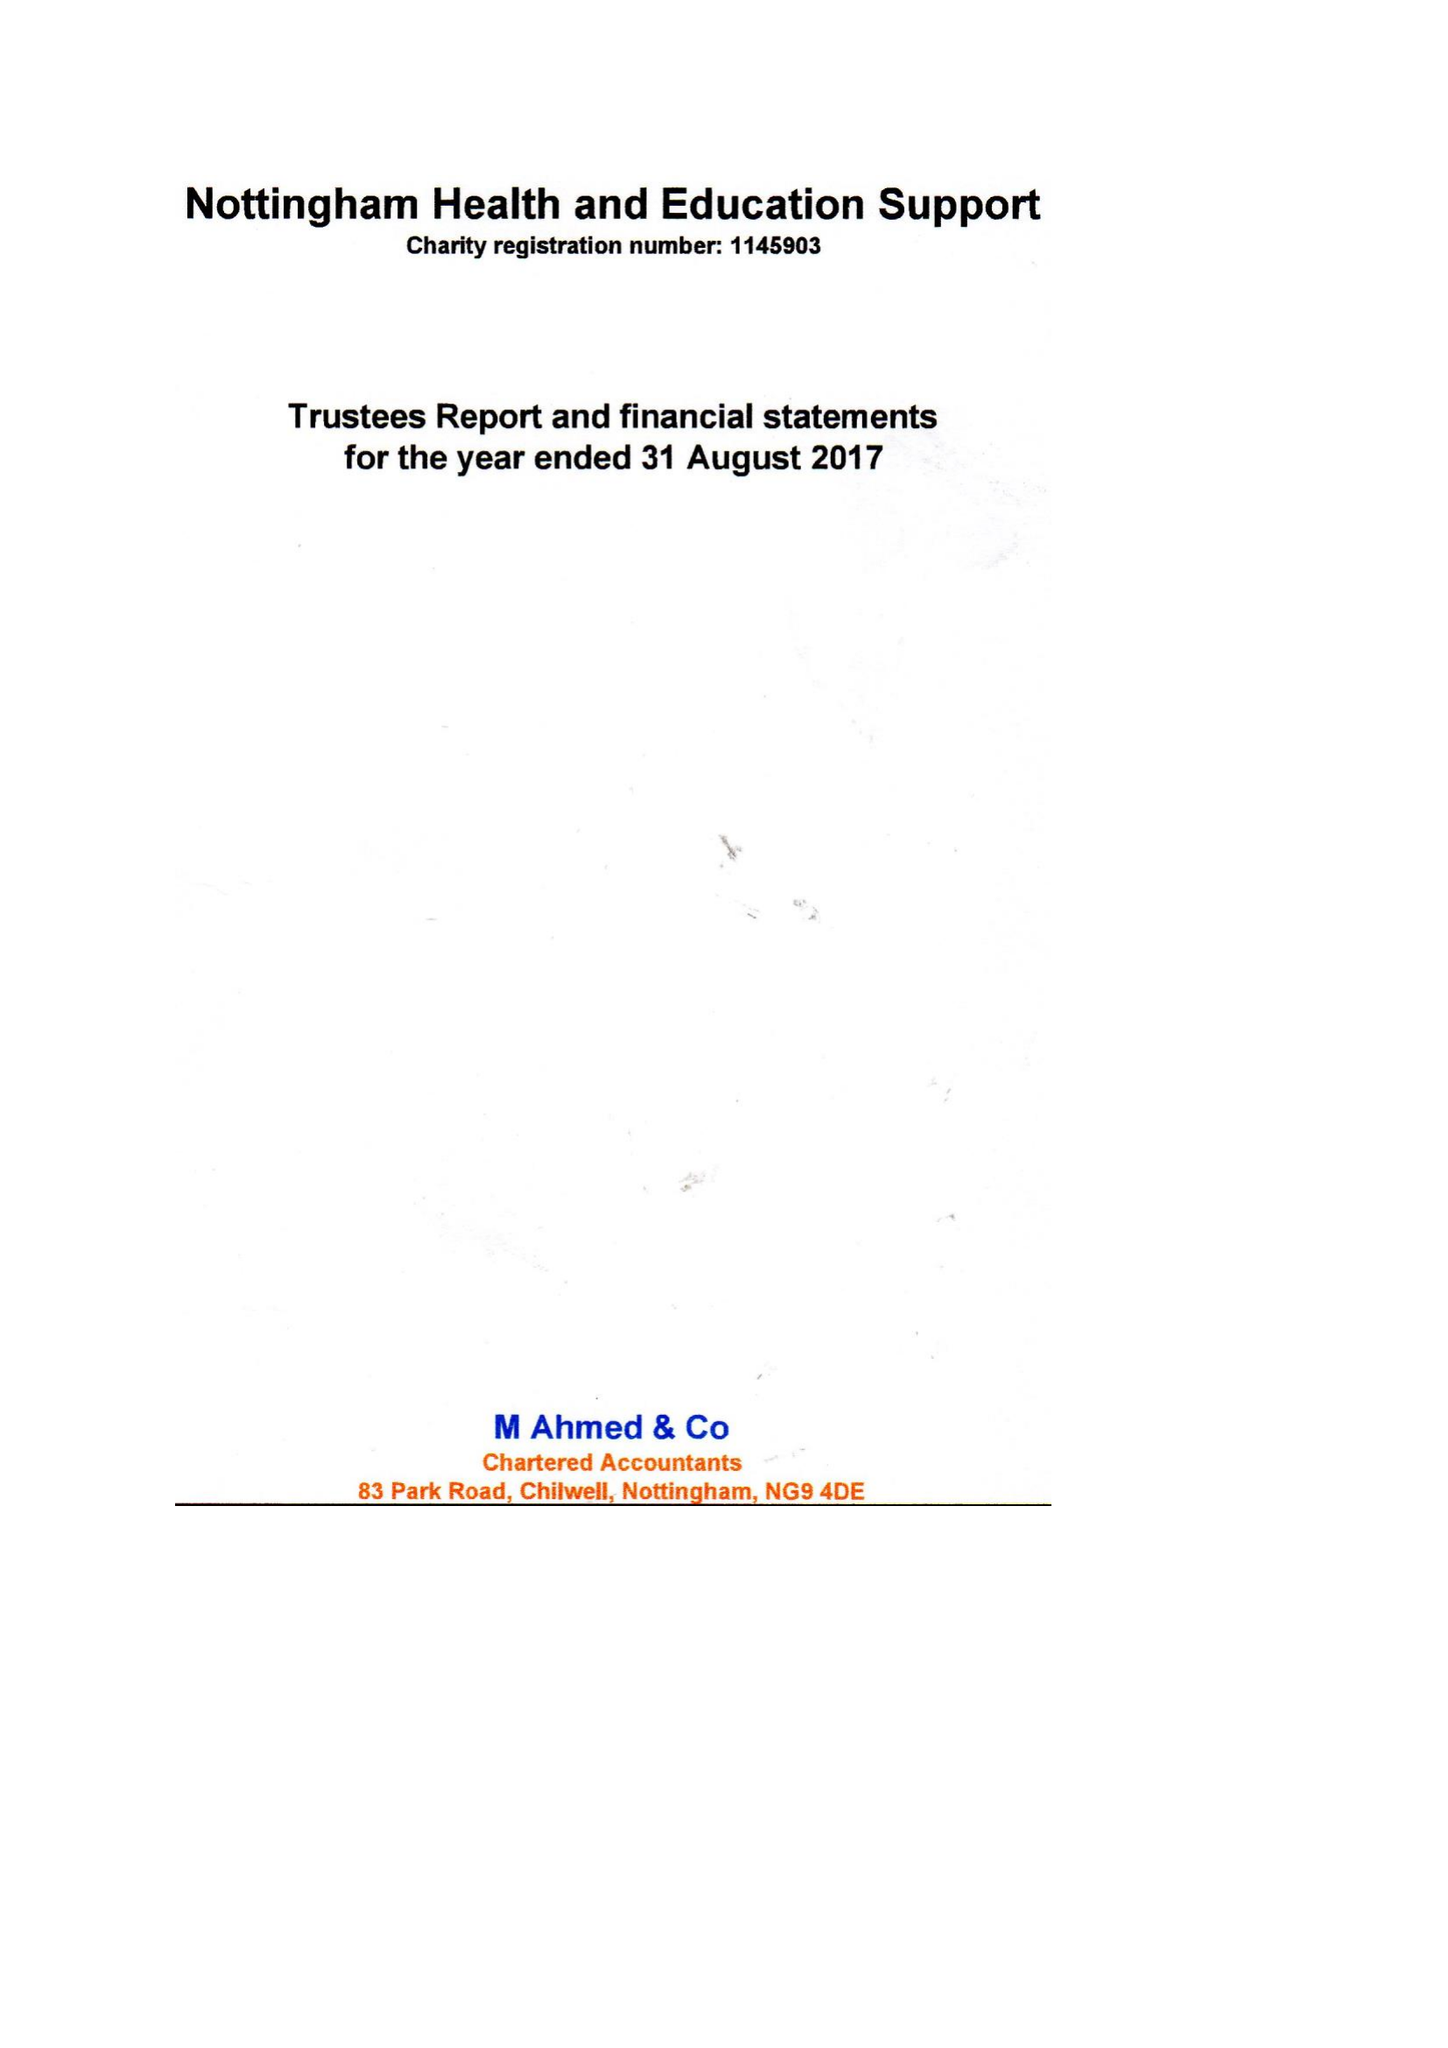What is the value for the income_annually_in_british_pounds?
Answer the question using a single word or phrase. 75460.00 